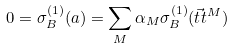<formula> <loc_0><loc_0><loc_500><loc_500>0 = \sigma _ { B } ^ { ( 1 ) } ( a ) & = \sum _ { M } \alpha _ { M } \sigma _ { B } ^ { ( 1 ) } ( \vec { t } { t } ^ { M } )</formula> 